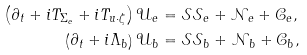Convert formula to latex. <formula><loc_0><loc_0><loc_500><loc_500>\left ( \partial _ { t } + i T _ { \Sigma _ { e } } + i T _ { u \cdot \zeta } \right ) \mathcal { U } _ { e } & = \mathcal { S S } _ { e } + \mathcal { N } _ { e } + \mathcal { C } _ { e } , \\ \left ( \partial _ { t } + i \Lambda _ { b } \right ) \mathcal { U } _ { b } & = \mathcal { S S } _ { b } + \mathcal { N } _ { b } + \mathcal { C } _ { b } ,</formula> 